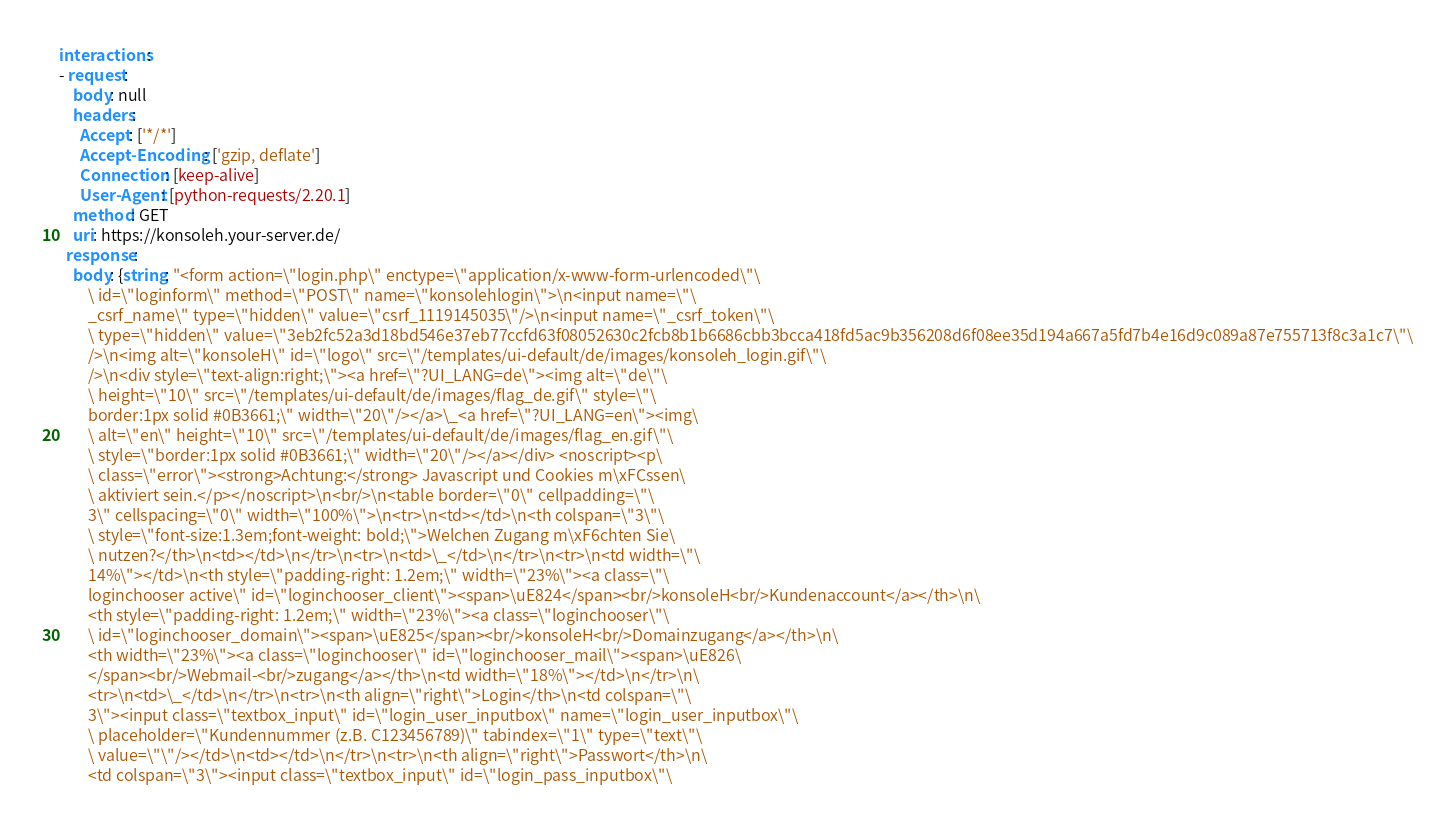<code> <loc_0><loc_0><loc_500><loc_500><_YAML_>interactions:
- request:
    body: null
    headers:
      Accept: ['*/*']
      Accept-Encoding: ['gzip, deflate']
      Connection: [keep-alive]
      User-Agent: [python-requests/2.20.1]
    method: GET
    uri: https://konsoleh.your-server.de/
  response:
    body: {string: "<form action=\"login.php\" enctype=\"application/x-www-form-urlencoded\"\
        \ id=\"loginform\" method=\"POST\" name=\"konsolehlogin\">\n<input name=\"\
        _csrf_name\" type=\"hidden\" value=\"csrf_1119145035\"/>\n<input name=\"_csrf_token\"\
        \ type=\"hidden\" value=\"3eb2fc52a3d18bd546e37eb77ccfd63f08052630c2fcb8b1b6686cbb3bcca418fd5ac9b356208d6f08ee35d194a667a5fd7b4e16d9c089a87e755713f8c3a1c7\"\
        />\n<img alt=\"konsoleH\" id=\"logo\" src=\"/templates/ui-default/de/images/konsoleh_login.gif\"\
        />\n<div style=\"text-align:right;\"><a href=\"?UI_LANG=de\"><img alt=\"de\"\
        \ height=\"10\" src=\"/templates/ui-default/de/images/flag_de.gif\" style=\"\
        border:1px solid #0B3661;\" width=\"20\"/></a>\_<a href=\"?UI_LANG=en\"><img\
        \ alt=\"en\" height=\"10\" src=\"/templates/ui-default/de/images/flag_en.gif\"\
        \ style=\"border:1px solid #0B3661;\" width=\"20\"/></a></div> <noscript><p\
        \ class=\"error\"><strong>Achtung:</strong> Javascript und Cookies m\xFCssen\
        \ aktiviert sein.</p></noscript>\n<br/>\n<table border=\"0\" cellpadding=\"\
        3\" cellspacing=\"0\" width=\"100%\">\n<tr>\n<td></td>\n<th colspan=\"3\"\
        \ style=\"font-size:1.3em;font-weight: bold;\">Welchen Zugang m\xF6chten Sie\
        \ nutzen?</th>\n<td></td>\n</tr>\n<tr>\n<td>\_</td>\n</tr>\n<tr>\n<td width=\"\
        14%\"></td>\n<th style=\"padding-right: 1.2em;\" width=\"23%\"><a class=\"\
        loginchooser active\" id=\"loginchooser_client\"><span>\uE824</span><br/>konsoleH<br/>Kundenaccount</a></th>\n\
        <th style=\"padding-right: 1.2em;\" width=\"23%\"><a class=\"loginchooser\"\
        \ id=\"loginchooser_domain\"><span>\uE825</span><br/>konsoleH<br/>Domainzugang</a></th>\n\
        <th width=\"23%\"><a class=\"loginchooser\" id=\"loginchooser_mail\"><span>\uE826\
        </span><br/>Webmail-<br/>zugang</a></th>\n<td width=\"18%\"></td>\n</tr>\n\
        <tr>\n<td>\_</td>\n</tr>\n<tr>\n<th align=\"right\">Login</th>\n<td colspan=\"\
        3\"><input class=\"textbox_input\" id=\"login_user_inputbox\" name=\"login_user_inputbox\"\
        \ placeholder=\"Kundennummer (z.B. C123456789)\" tabindex=\"1\" type=\"text\"\
        \ value=\"\"/></td>\n<td></td>\n</tr>\n<tr>\n<th align=\"right\">Passwort</th>\n\
        <td colspan=\"3\"><input class=\"textbox_input\" id=\"login_pass_inputbox\"\</code> 